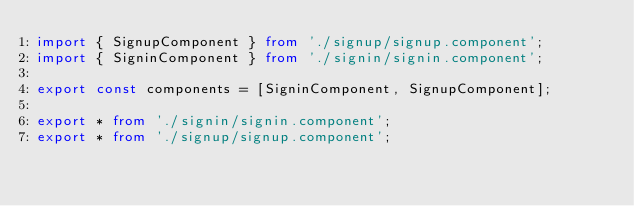Convert code to text. <code><loc_0><loc_0><loc_500><loc_500><_TypeScript_>import { SignupComponent } from './signup/signup.component';
import { SigninComponent } from './signin/signin.component';

export const components = [SigninComponent, SignupComponent];

export * from './signin/signin.component';
export * from './signup/signup.component';
</code> 